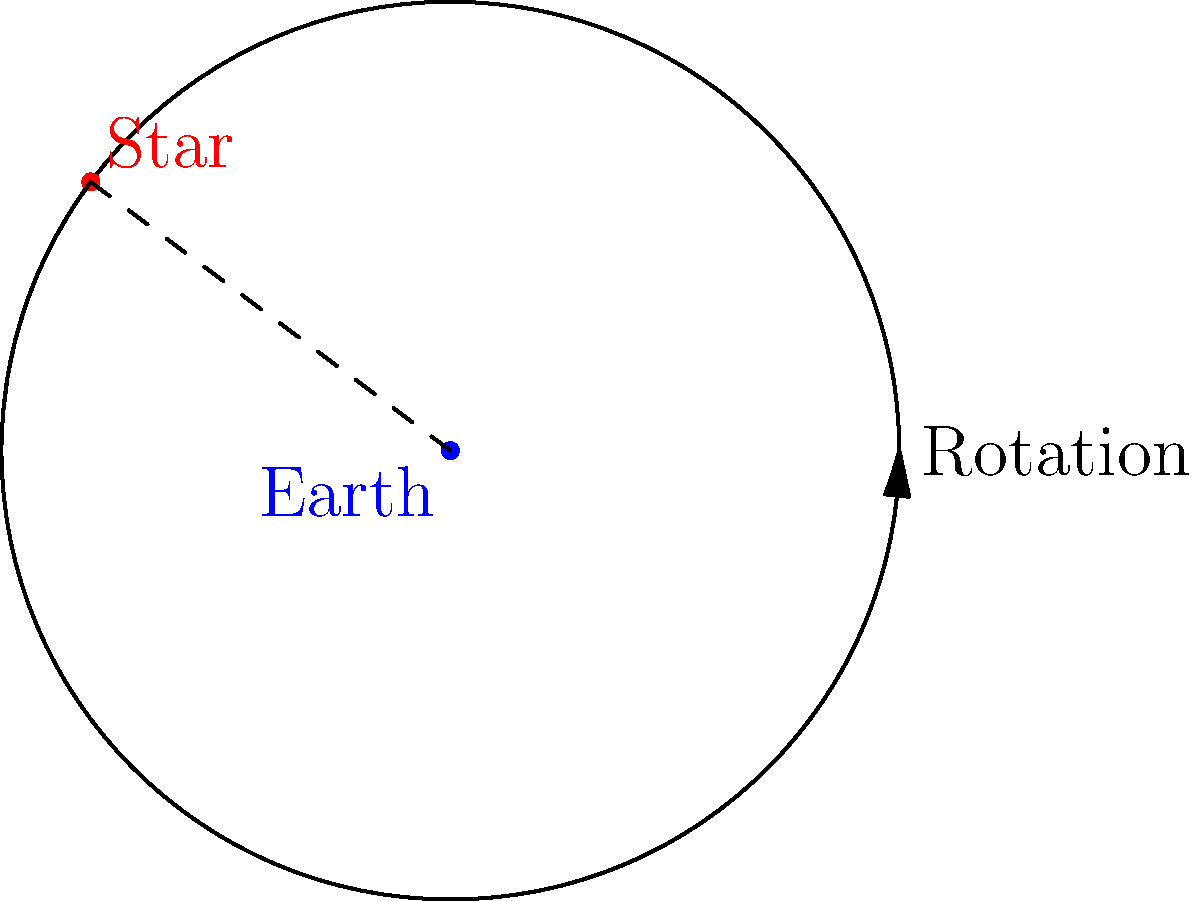As a seasoned political strategist, you understand the importance of timing in campaigns. Similarly, the apparent motion of stars in the night sky is all about timing and perspective. If Earth completes one full rotation in 24 hours, how many degrees does a star appear to move across the sky in 1 hour? To solve this problem, let's break it down step-by-step:

1. First, we need to understand the relationship between Earth's rotation and the apparent motion of stars:
   - Earth rotates 360° in 24 hours (one full day)
   - This rotation causes stars to appear to move across the sky

2. We can set up a proportion to solve for the degrees moved in 1 hour:
   $\frac{360°}{24 \text{ hours}} = \frac{x°}{1 \text{ hour}}$

3. Cross-multiply:
   $360° \cdot 1 \text{ hour} = 24 \text{ hours} \cdot x°$

4. Solve for $x$:
   $x° = \frac{360° \cdot 1 \text{ hour}}{24 \text{ hours}} = 15°$

5. Interpret the result:
   In 1 hour, a star appears to move 15° across the sky due to Earth's rotation.

This concept of timing and perspective in astronomy can be related to political campaigns. Just as the apparent motion of stars is determined by Earth's rotation, the effectiveness of political messaging often depends on the timing and perspective from which it's delivered.
Answer: 15° 